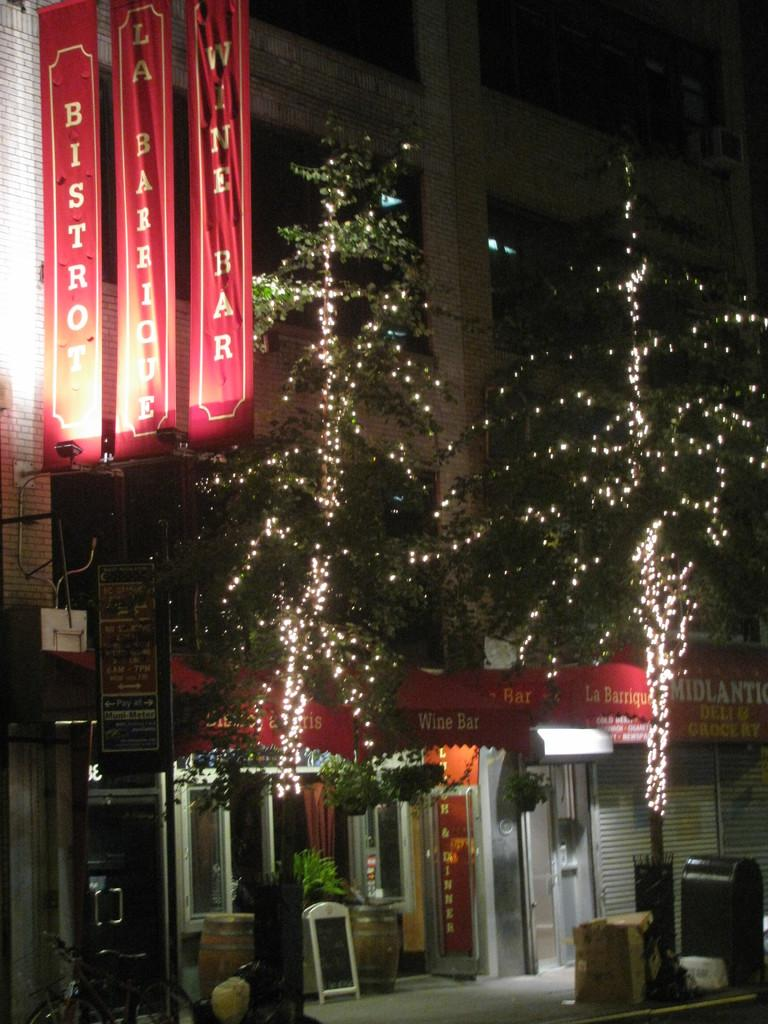What type of structure is visible in the image? There is a building in the image. What can be seen near the building? There are banners and boards near the building. What is the decoration in front of the building? There are trees with lights and barrels in front of the building. Are there any other signs or displays in front of the building? Yes, there are additional boards in front of the building. What type of plastic material is used to make the reward in the image? There is no reward present in the image, and therefore no plastic material can be associated with it. 